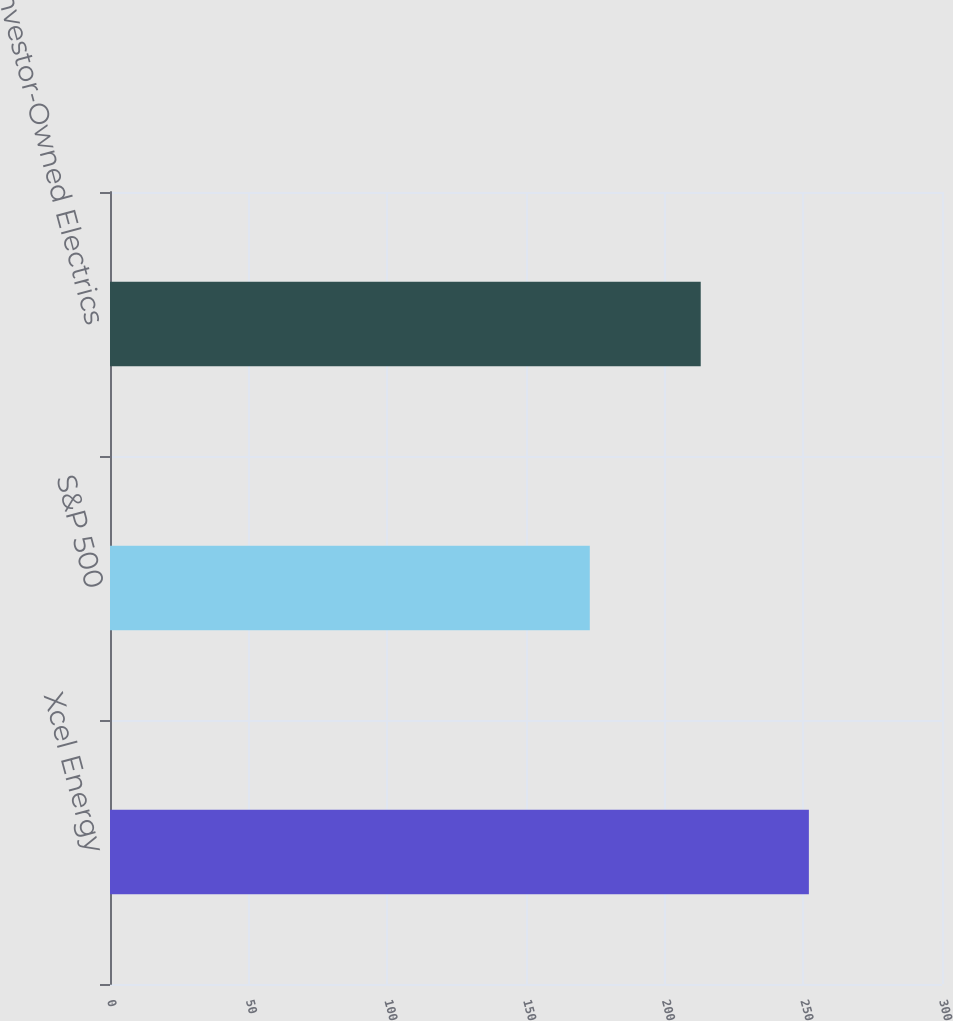Convert chart. <chart><loc_0><loc_0><loc_500><loc_500><bar_chart><fcel>Xcel Energy<fcel>S&P 500<fcel>EEI Investor-Owned Electrics<nl><fcel>252<fcel>173<fcel>213<nl></chart> 